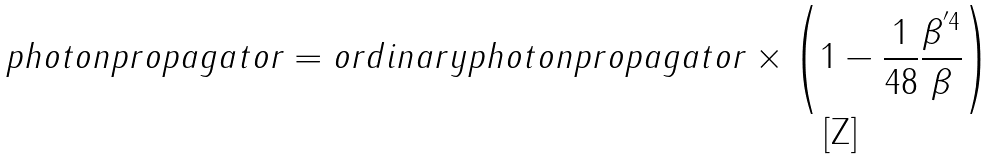<formula> <loc_0><loc_0><loc_500><loc_500>p h o t o n p r o p a g a t o r = o r d i n a r y p h o t o n p r o p a g a t o r \times \left ( 1 - \frac { 1 } { 4 8 } \frac { \beta ^ { ^ { \prime } 4 } } { \beta } \right )</formula> 